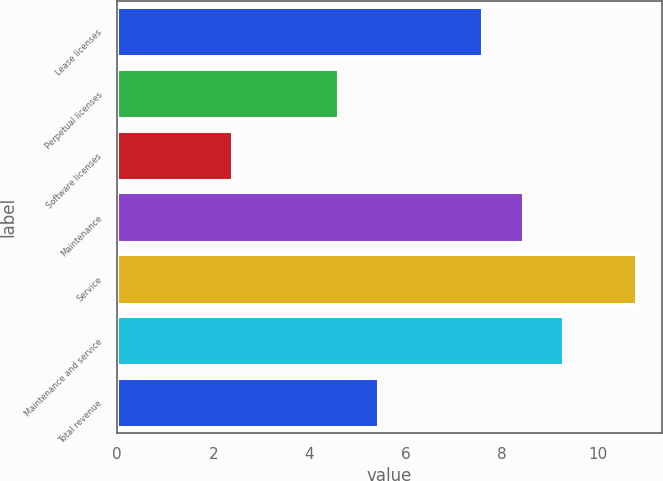<chart> <loc_0><loc_0><loc_500><loc_500><bar_chart><fcel>Lease licenses<fcel>Perpetual licenses<fcel>Software licenses<fcel>Maintenance<fcel>Service<fcel>Maintenance and service<fcel>Total revenue<nl><fcel>7.6<fcel>4.6<fcel>2.4<fcel>8.44<fcel>10.8<fcel>9.28<fcel>5.44<nl></chart> 